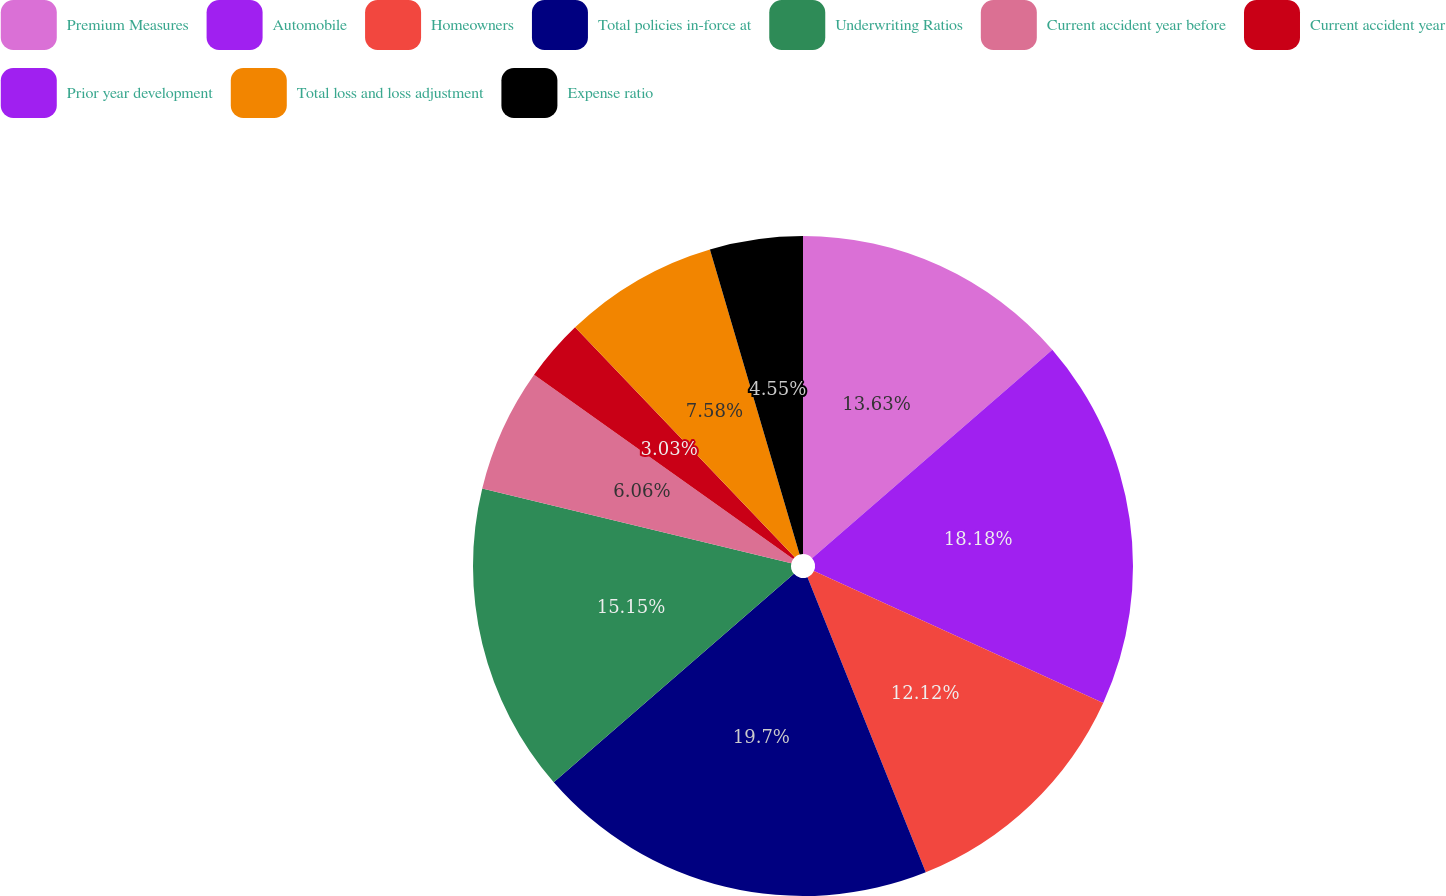Convert chart to OTSL. <chart><loc_0><loc_0><loc_500><loc_500><pie_chart><fcel>Premium Measures<fcel>Automobile<fcel>Homeowners<fcel>Total policies in-force at<fcel>Underwriting Ratios<fcel>Current accident year before<fcel>Current accident year<fcel>Prior year development<fcel>Total loss and loss adjustment<fcel>Expense ratio<nl><fcel>13.63%<fcel>18.18%<fcel>12.12%<fcel>19.69%<fcel>15.15%<fcel>6.06%<fcel>3.03%<fcel>0.0%<fcel>7.58%<fcel>4.55%<nl></chart> 